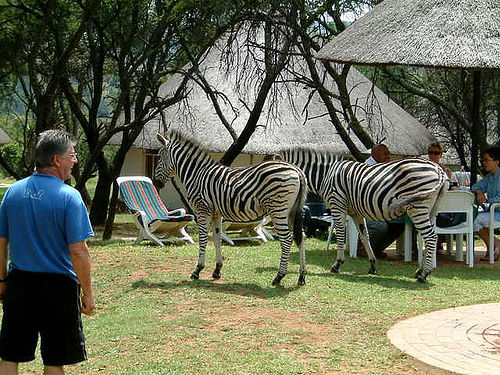What are the people in the background doing? The group of people in the background appears to be engaged in a casual outdoor gathering, possibly enjoying a meal or a conversation at a table under the shade of a thatched umbrella. 